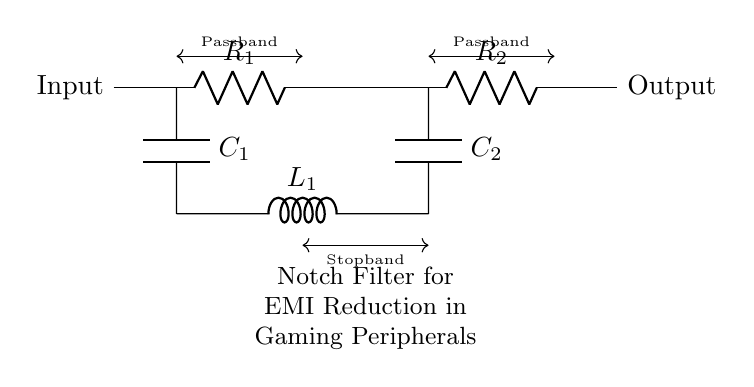What is the type of the filter shown in the circuit? The circuit is a notch filter, which is specifically designed to eliminate a narrow band of frequencies while allowing other frequencies to pass through. This is indicated in the label of the circuit.
Answer: Notch filter How many resistors are present in the circuit? The circuit diagram shows two resistors, labeled as R1 and R2. They are the components that manage the resistance values in the circuit.
Answer: Two What is the role of the inductor in this circuit? The inductor (L1) in the notch filter creates a resonant circuit with the capacitors (C1 and C2), which helps to determine the stopband characteristics of the filter, effectively reducing electromagnetic interference.
Answer: Reduces EMI What is the total number of capacitors in the circuit? There are two capacitors in the circuit, labeled as C1 and C2. The diagram clearly outlines both components, confirming their presence and role in the filter.
Answer: Two In which section of the circuit does the stopband occur? The stopband is indicated in the circuit between the two capacitors, where frequencies are not allowed to pass through. This area is marked as the region responsible for suppression.
Answer: Between C1 and C2 What is the function of R1 and R2 in the circuit? The resistors R1 and R2 are used to set the impedance of the notch filter, contributing to the overall frequency response of the circuit. They work along with other components to ensure the desired filtering effect is achieved.
Answer: Set impedance 